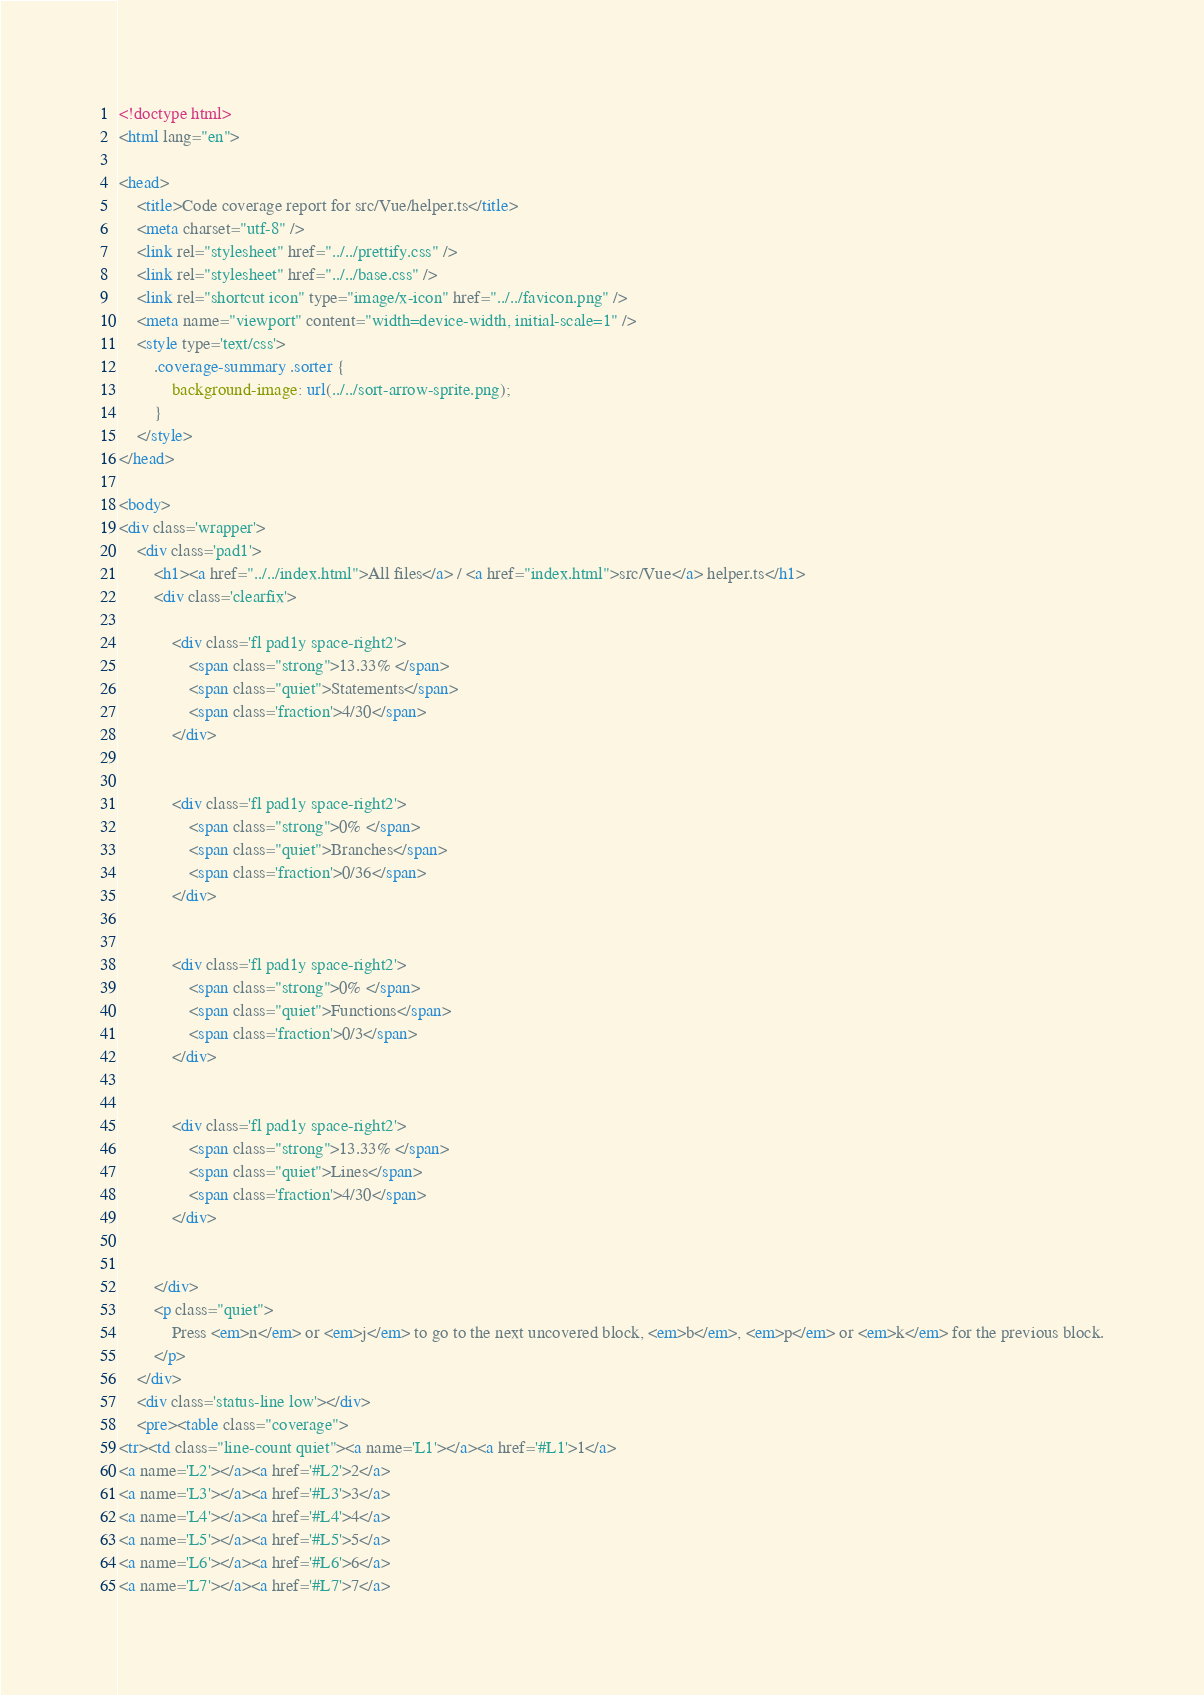<code> <loc_0><loc_0><loc_500><loc_500><_HTML_>
<!doctype html>
<html lang="en">

<head>
    <title>Code coverage report for src/Vue/helper.ts</title>
    <meta charset="utf-8" />
    <link rel="stylesheet" href="../../prettify.css" />
    <link rel="stylesheet" href="../../base.css" />
    <link rel="shortcut icon" type="image/x-icon" href="../../favicon.png" />
    <meta name="viewport" content="width=device-width, initial-scale=1" />
    <style type='text/css'>
        .coverage-summary .sorter {
            background-image: url(../../sort-arrow-sprite.png);
        }
    </style>
</head>
    
<body>
<div class='wrapper'>
    <div class='pad1'>
        <h1><a href="../../index.html">All files</a> / <a href="index.html">src/Vue</a> helper.ts</h1>
        <div class='clearfix'>
            
            <div class='fl pad1y space-right2'>
                <span class="strong">13.33% </span>
                <span class="quiet">Statements</span>
                <span class='fraction'>4/30</span>
            </div>
        
            
            <div class='fl pad1y space-right2'>
                <span class="strong">0% </span>
                <span class="quiet">Branches</span>
                <span class='fraction'>0/36</span>
            </div>
        
            
            <div class='fl pad1y space-right2'>
                <span class="strong">0% </span>
                <span class="quiet">Functions</span>
                <span class='fraction'>0/3</span>
            </div>
        
            
            <div class='fl pad1y space-right2'>
                <span class="strong">13.33% </span>
                <span class="quiet">Lines</span>
                <span class='fraction'>4/30</span>
            </div>
        
            
        </div>
        <p class="quiet">
            Press <em>n</em> or <em>j</em> to go to the next uncovered block, <em>b</em>, <em>p</em> or <em>k</em> for the previous block.
        </p>
    </div>
    <div class='status-line low'></div>
    <pre><table class="coverage">
<tr><td class="line-count quiet"><a name='L1'></a><a href='#L1'>1</a>
<a name='L2'></a><a href='#L2'>2</a>
<a name='L3'></a><a href='#L3'>3</a>
<a name='L4'></a><a href='#L4'>4</a>
<a name='L5'></a><a href='#L5'>5</a>
<a name='L6'></a><a href='#L6'>6</a>
<a name='L7'></a><a href='#L7'>7</a></code> 